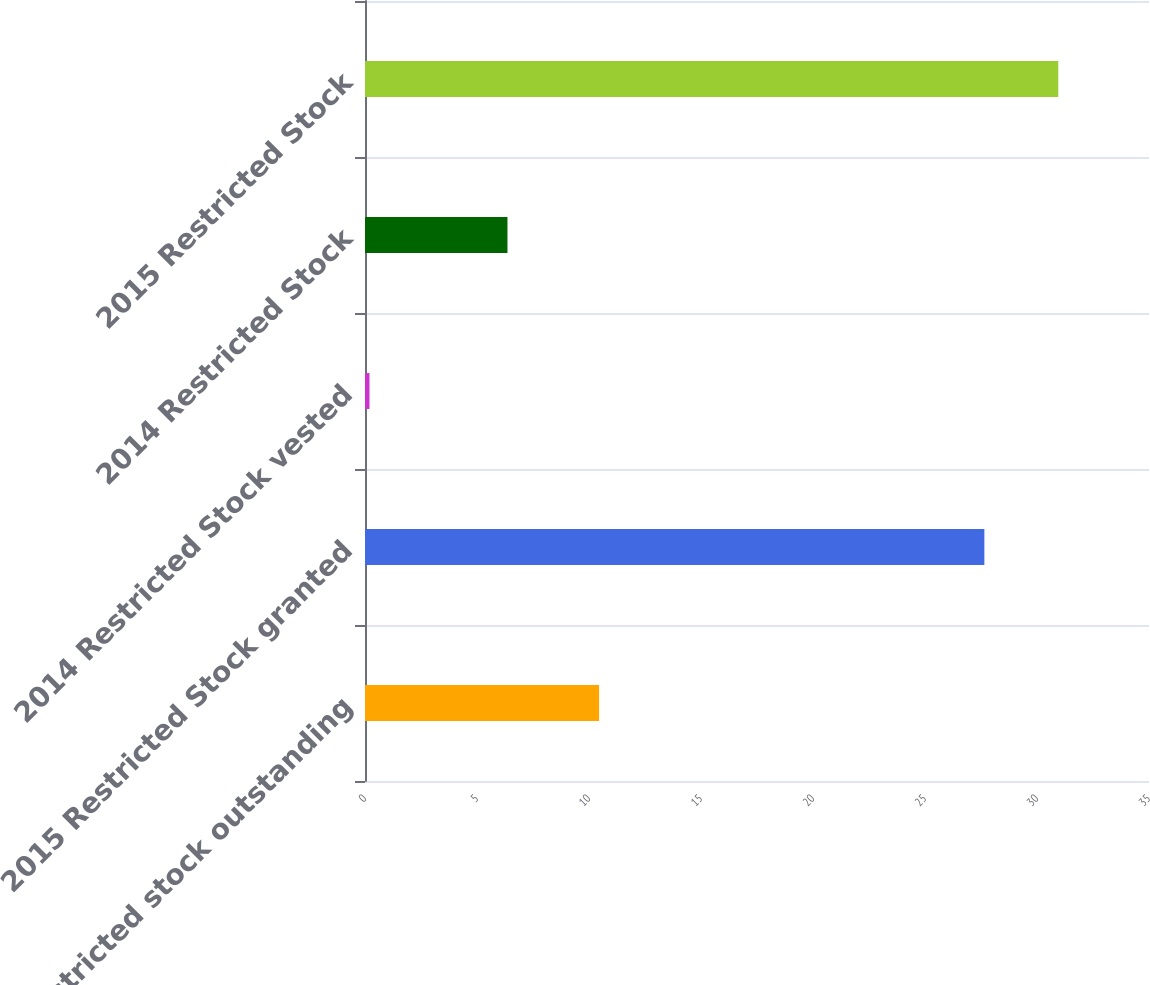Convert chart to OTSL. <chart><loc_0><loc_0><loc_500><loc_500><bar_chart><fcel>Restricted stock outstanding<fcel>2015 Restricted Stock granted<fcel>2014 Restricted Stock vested<fcel>2014 Restricted Stock<fcel>2015 Restricted Stock<nl><fcel>10.45<fcel>27.65<fcel>0.2<fcel>6.36<fcel>30.95<nl></chart> 